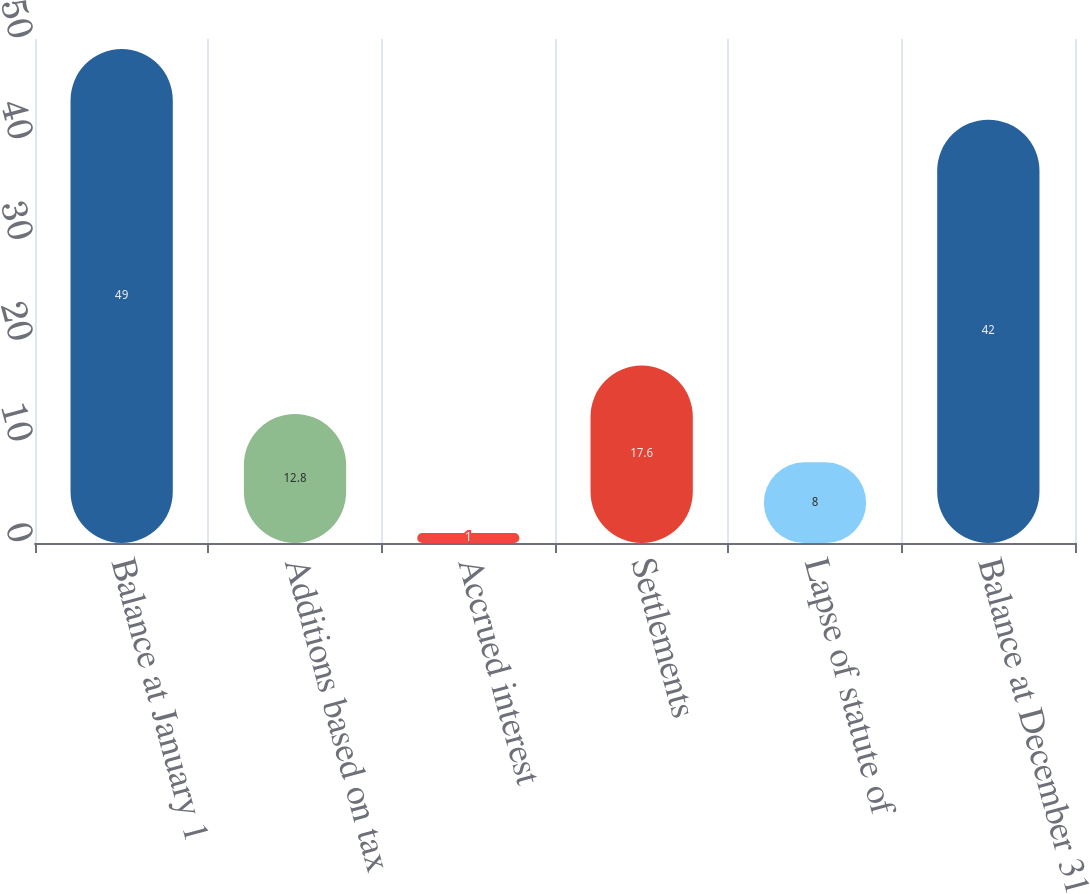Convert chart. <chart><loc_0><loc_0><loc_500><loc_500><bar_chart><fcel>Balance at January 1<fcel>Additions based on tax<fcel>Accrued interest<fcel>Settlements<fcel>Lapse of statute of<fcel>Balance at December 31<nl><fcel>49<fcel>12.8<fcel>1<fcel>17.6<fcel>8<fcel>42<nl></chart> 